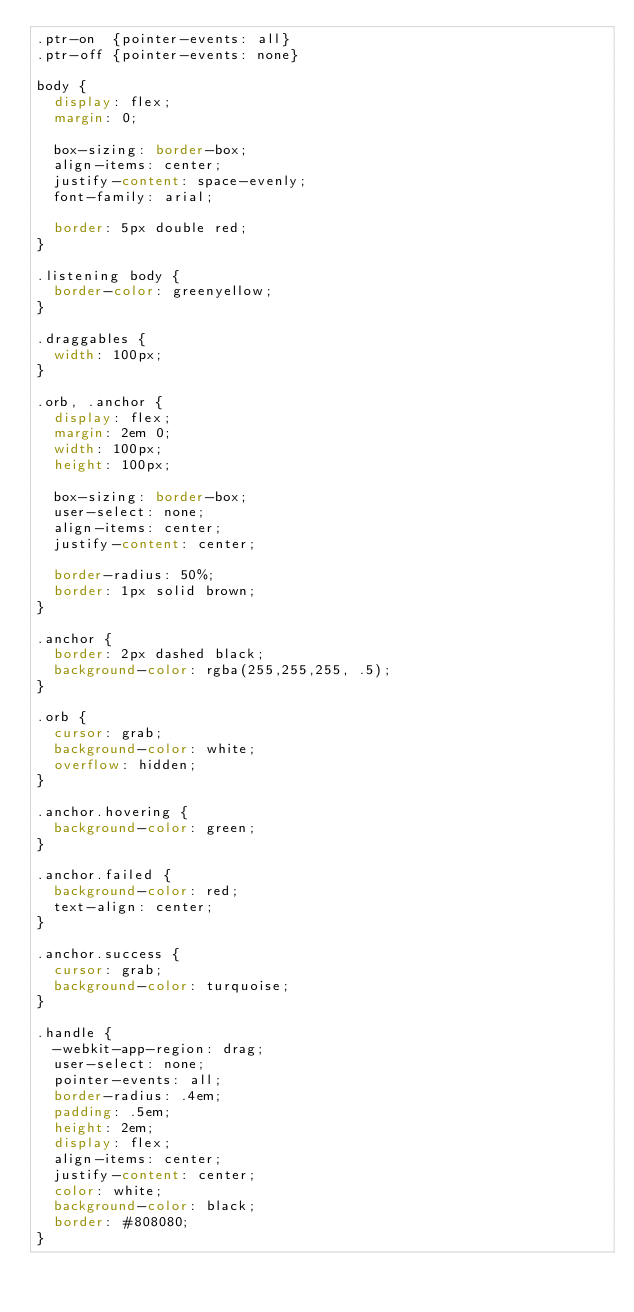Convert code to text. <code><loc_0><loc_0><loc_500><loc_500><_CSS_>.ptr-on  {pointer-events: all}
.ptr-off {pointer-events: none}

body {
  display: flex;
  margin: 0;

  box-sizing: border-box;
  align-items: center;
  justify-content: space-evenly;
  font-family: arial;

  border: 5px double red;
}

.listening body {
  border-color: greenyellow;
}

.draggables {
  width: 100px;
}

.orb, .anchor {
  display: flex;
  margin: 2em 0;
  width: 100px;
  height: 100px;

  box-sizing: border-box;
  user-select: none;
  align-items: center;
  justify-content: center;

  border-radius: 50%;
  border: 1px solid brown;
}

.anchor {
  border: 2px dashed black;
  background-color: rgba(255,255,255, .5);
}

.orb {
  cursor: grab;
  background-color: white;
  overflow: hidden;
}

.anchor.hovering {
  background-color: green;
}

.anchor.failed {
  background-color: red;
  text-align: center;
}

.anchor.success {
  cursor: grab;
  background-color: turquoise;
}

.handle {
  -webkit-app-region: drag;
  user-select: none;
  pointer-events: all;
  border-radius: .4em;
  padding: .5em;
  height: 2em;
  display: flex;
  align-items: center;
  justify-content: center;
  color: white;
  background-color: black;
  border: #808080;
}</code> 